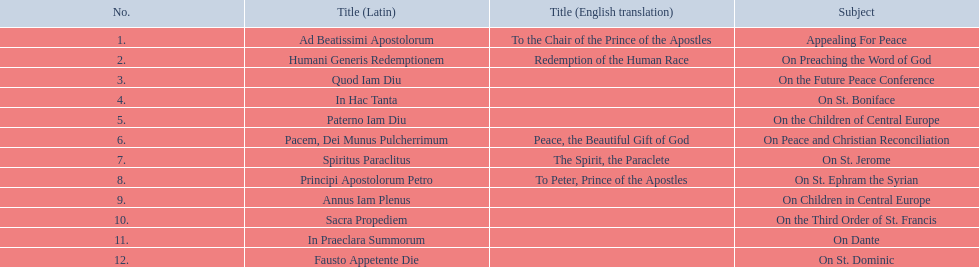Besides january, how many encyclicals were there in 1921? 2. 